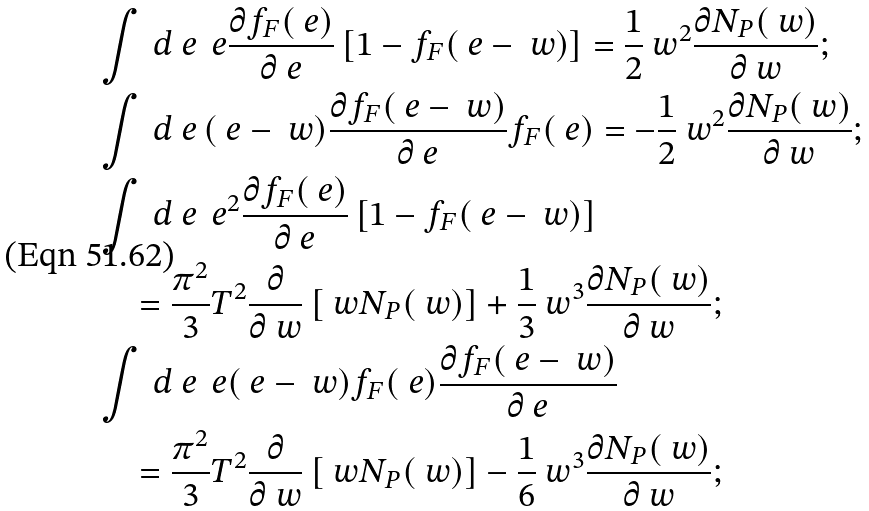<formula> <loc_0><loc_0><loc_500><loc_500>& \int \, d \ e \, \ e \frac { \partial f _ { F } ( \ e ) } { \partial \ e } \left [ 1 - f _ { F } ( \ e - \ w ) \right ] = \frac { 1 } { 2 } \ w ^ { 2 } \frac { \partial N _ { P } ( \ w ) } { \partial \ w } ; \\ & \int \, d \ e \, ( \ e - \ w ) \frac { \partial f _ { F } ( \ e - \ w ) } { \partial \ e } f _ { F } ( \ e ) = - \frac { 1 } { 2 } \ w ^ { 2 } \frac { \partial N _ { P } ( \ w ) } { \partial \ w } ; \\ & \int \, d \ e \, \ e ^ { 2 } \frac { \partial f _ { F } ( \ e ) } { \partial \ e } \left [ 1 - f _ { F } ( \ e - \ w ) \right ] \\ & \quad = \frac { \pi ^ { 2 } } { 3 } T ^ { 2 } \frac { \partial } { \partial \ w } \left [ \ w N _ { P } ( \ w ) \right ] + \frac { 1 } { 3 } \ w ^ { 3 } \frac { \partial N _ { P } ( \ w ) } { \partial \ w } ; \\ & \int \, d \ e \, \ e ( \ e - \ w ) f _ { F } ( \ e ) \frac { \partial f _ { F } ( \ e - \ w ) } { \partial \ e } \\ & \quad = \frac { \pi ^ { 2 } } { 3 } T ^ { 2 } \frac { \partial } { \partial \ w } \left [ \ w N _ { P } ( \ w ) \right ] - \frac { 1 } { 6 } \ w ^ { 3 } \frac { \partial N _ { P } ( \ w ) } { \partial \ w } ;</formula> 